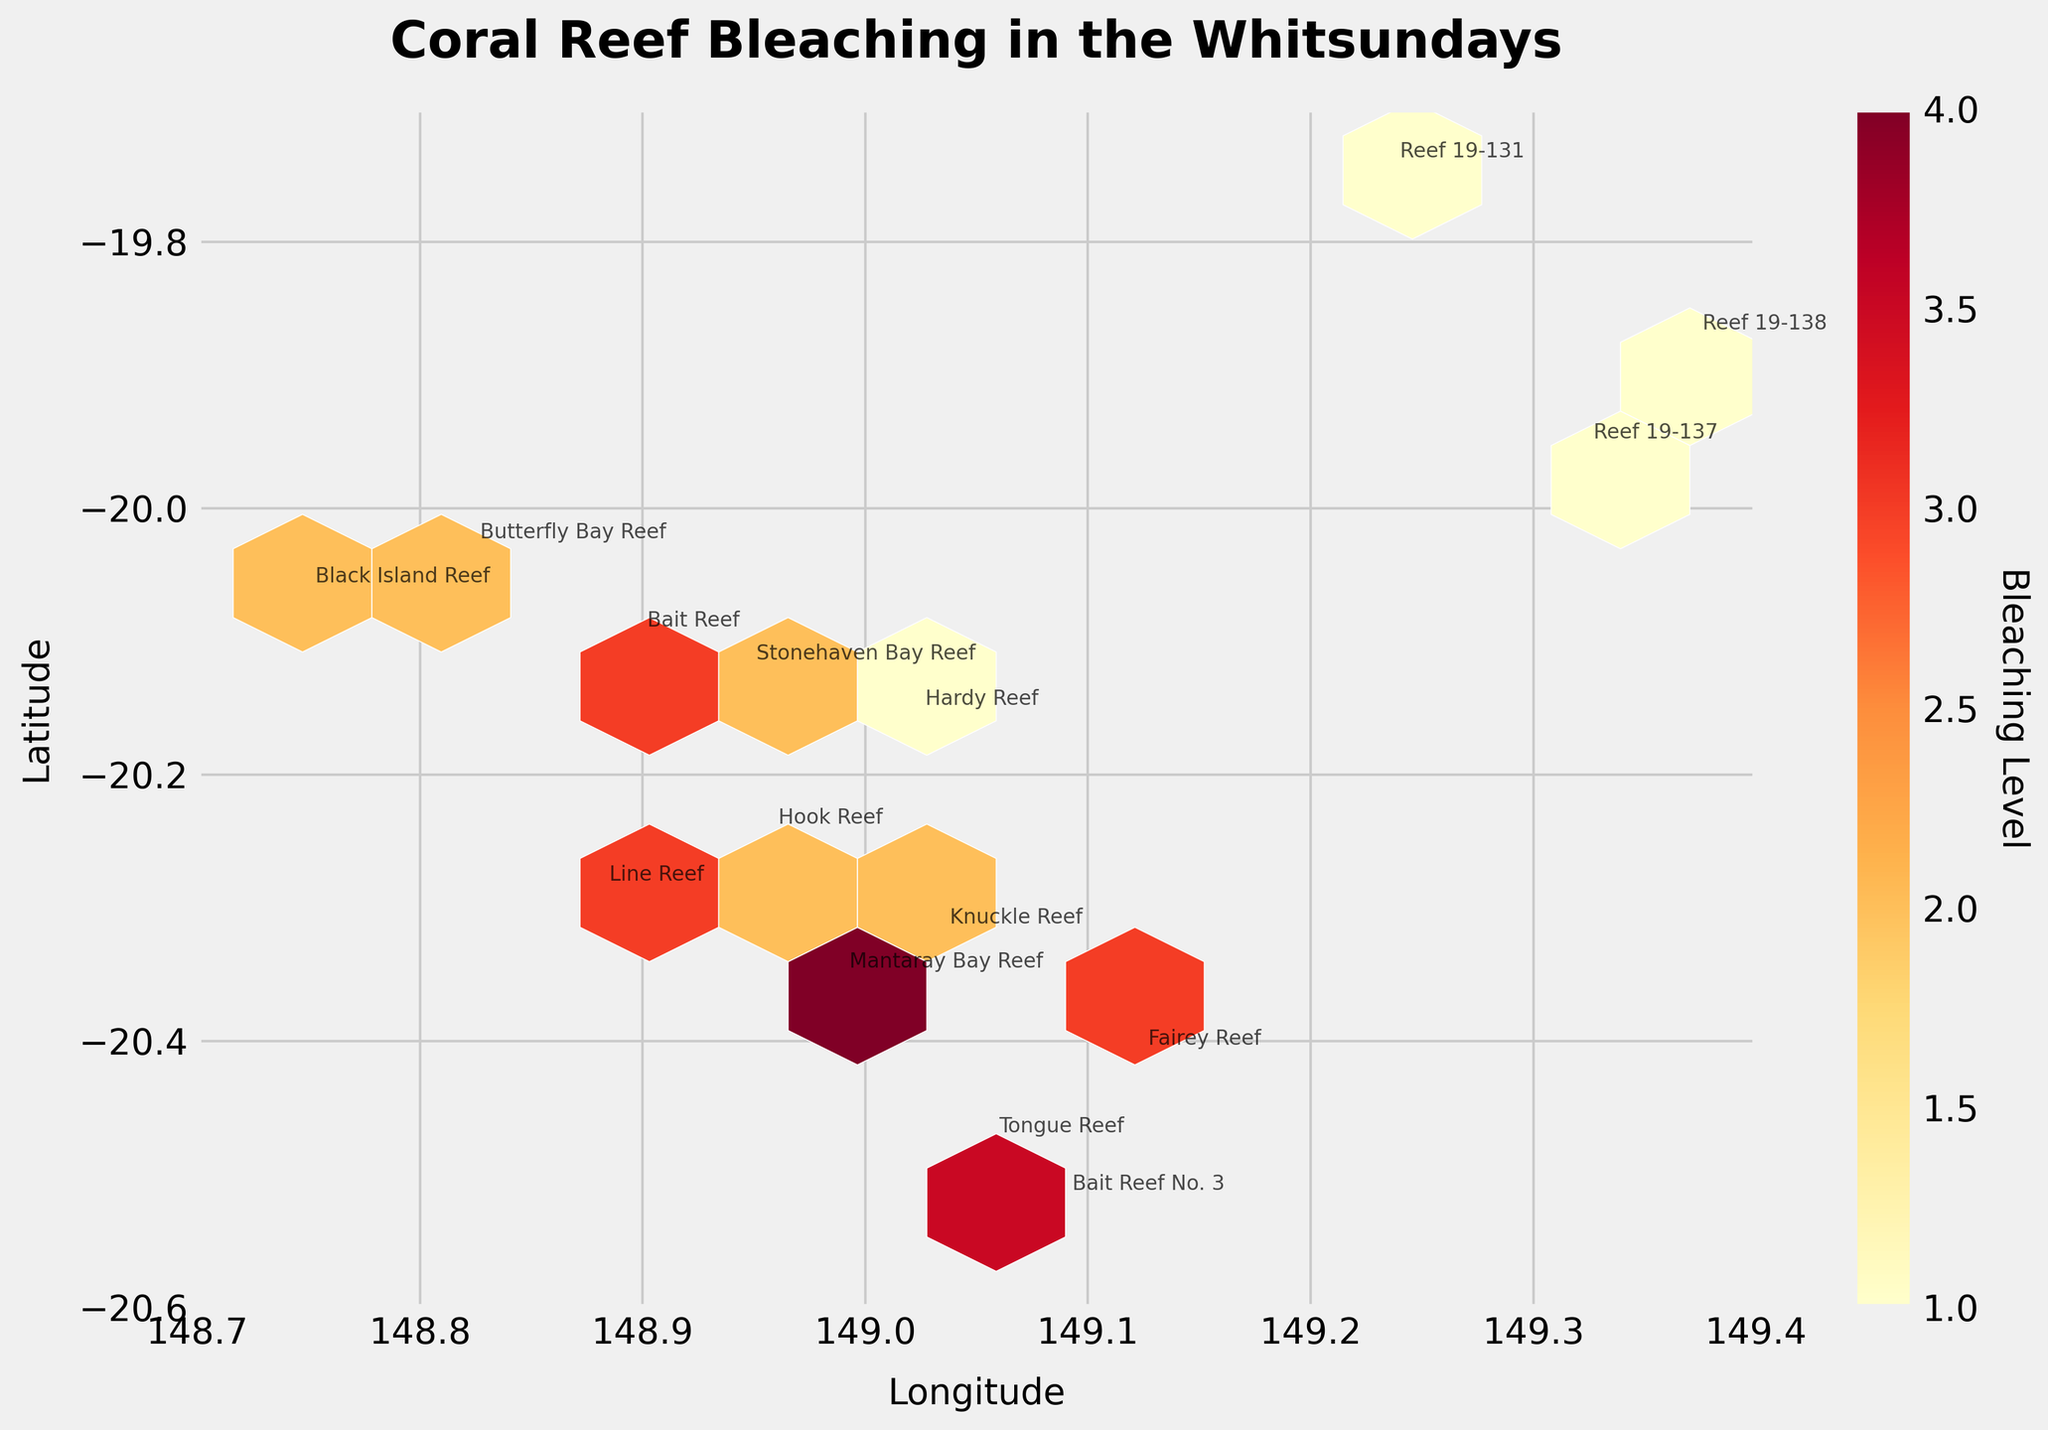What is the title of the plot? The title is usually located at the top of the figure, providing a concise description of the data visualized. Here, it indicates the plot is about coral reef bleaching in the Whitsundays.
Answer: Coral Reef Bleaching in the Whitsundays What does the color scale represent in the plot? The color scale, often depicted in the color bar on the side of the plot, shows what a gradient of color represents in terms of data values. In this case, it shows the level of bleaching on a scale from low to high.
Answer: Bleaching Level Which reef shows the highest level of bleaching, and what is that level? By observing the plot and identifying the annotation with the highest bleaching color, we can see that Tongue Reef and Mantaray Bay Reef both have the highest bleaching level.
Answer: 4 Which reef is located at approximately -20.1 latitude and 148.9 longitude? By matching the coordinates with annotations in the plot, this reef can be identified. In this case, Bait Reef is located at these coordinates.
Answer: Bait Reef How many reefs are represented in the plot? We can count the number of distinct annotations for each reef name in the figure to get the total number of reefs. Each reef is labeled uniquely in the plot.
Answer: 15 What is the range of the latitude and longitude shown in the plot? The limits of the x and y axes provide the range for longitude and latitude, respectively. These ranges are explicitly labeled on the axes.
Answer: Latitude: -20.6 to -19.7, Longitude: 148.7 to 149.4 Which reef has the highest recovery score? The recovery score values are annotated next to the reef names. By scanning these scores, Reef 19-137 and Reef 19-138 have the highest recovery score of 5.
Answer: Reef 19-137 and Reef 19-138 What is the average bleaching level of all reefs? Sum the bleaching levels of all the reefs and divide by the number of reefs to find the average. The calculation is (2+1+3+2+1+4+2+3+1+3+2+1+4+2+3)/15 = 2.13.
Answer: 2.13 Which reef is placed at the highest latitude? The highest latitude can be identified by locating the northernmost point (highest y-axis value) on the plot. This reef is labeled.
Answer: Reef 19-131 Compare the bleaching levels of Hook Reef and Knuckle Reef. Which one has a higher level? By comparing the colors/hexagons and annotations at the locations of these reefs, Hook Reef and Knuckle Reef both have a bleaching level of 2.
Answer: Equal at level 2 